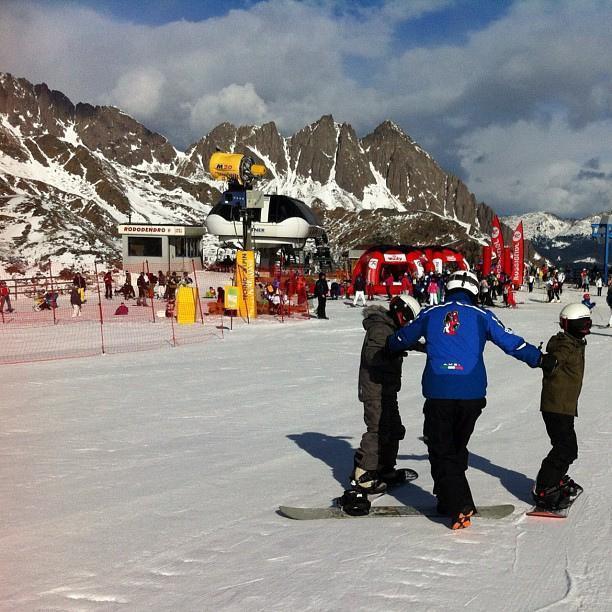How many people are in the picture?
Give a very brief answer. 4. 